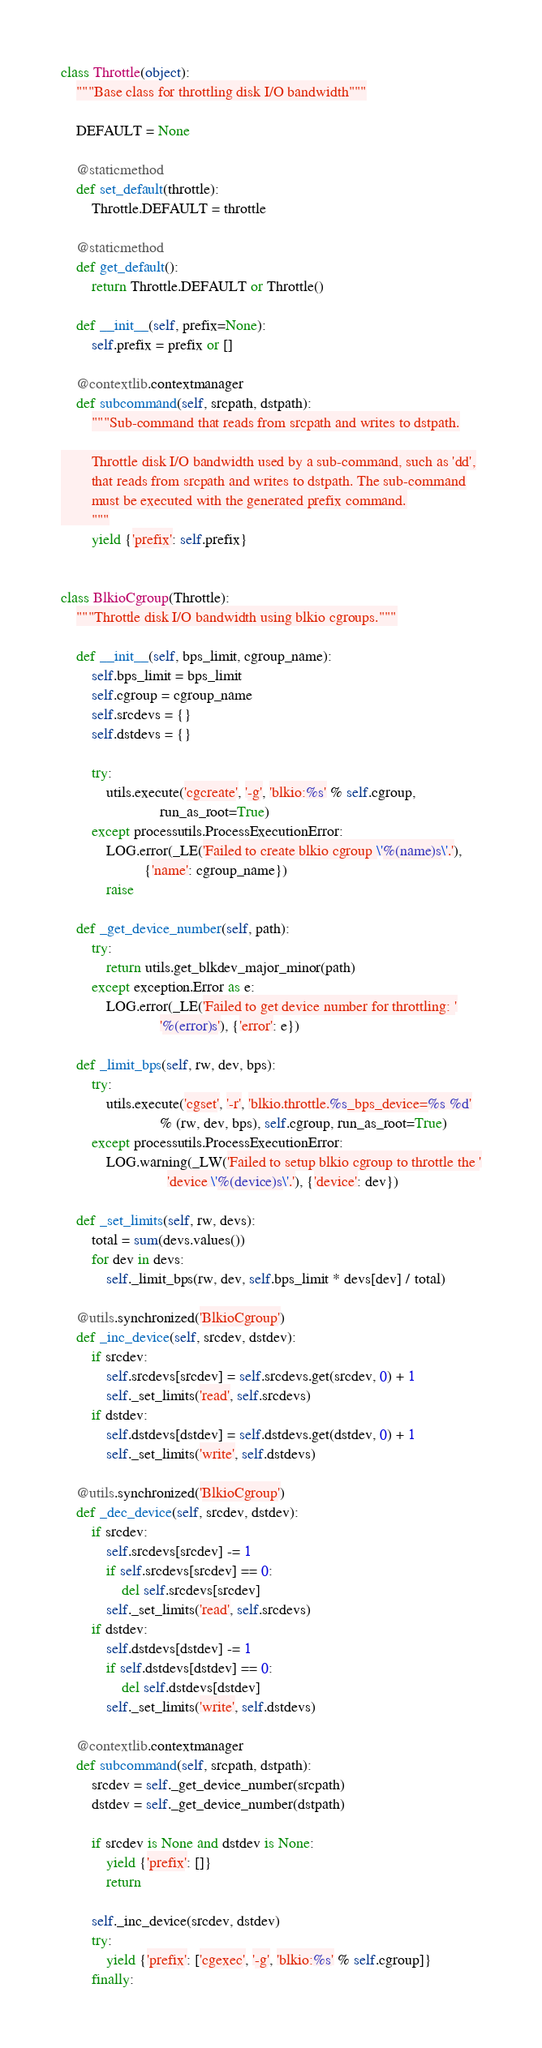<code> <loc_0><loc_0><loc_500><loc_500><_Python_>
class Throttle(object):
    """Base class for throttling disk I/O bandwidth"""

    DEFAULT = None

    @staticmethod
    def set_default(throttle):
        Throttle.DEFAULT = throttle

    @staticmethod
    def get_default():
        return Throttle.DEFAULT or Throttle()

    def __init__(self, prefix=None):
        self.prefix = prefix or []

    @contextlib.contextmanager
    def subcommand(self, srcpath, dstpath):
        """Sub-command that reads from srcpath and writes to dstpath.

        Throttle disk I/O bandwidth used by a sub-command, such as 'dd',
        that reads from srcpath and writes to dstpath. The sub-command
        must be executed with the generated prefix command.
        """
        yield {'prefix': self.prefix}


class BlkioCgroup(Throttle):
    """Throttle disk I/O bandwidth using blkio cgroups."""

    def __init__(self, bps_limit, cgroup_name):
        self.bps_limit = bps_limit
        self.cgroup = cgroup_name
        self.srcdevs = {}
        self.dstdevs = {}

        try:
            utils.execute('cgcreate', '-g', 'blkio:%s' % self.cgroup,
                          run_as_root=True)
        except processutils.ProcessExecutionError:
            LOG.error(_LE('Failed to create blkio cgroup \'%(name)s\'.'),
                      {'name': cgroup_name})
            raise

    def _get_device_number(self, path):
        try:
            return utils.get_blkdev_major_minor(path)
        except exception.Error as e:
            LOG.error(_LE('Failed to get device number for throttling: '
                          '%(error)s'), {'error': e})

    def _limit_bps(self, rw, dev, bps):
        try:
            utils.execute('cgset', '-r', 'blkio.throttle.%s_bps_device=%s %d'
                          % (rw, dev, bps), self.cgroup, run_as_root=True)
        except processutils.ProcessExecutionError:
            LOG.warning(_LW('Failed to setup blkio cgroup to throttle the '
                            'device \'%(device)s\'.'), {'device': dev})

    def _set_limits(self, rw, devs):
        total = sum(devs.values())
        for dev in devs:
            self._limit_bps(rw, dev, self.bps_limit * devs[dev] / total)

    @utils.synchronized('BlkioCgroup')
    def _inc_device(self, srcdev, dstdev):
        if srcdev:
            self.srcdevs[srcdev] = self.srcdevs.get(srcdev, 0) + 1
            self._set_limits('read', self.srcdevs)
        if dstdev:
            self.dstdevs[dstdev] = self.dstdevs.get(dstdev, 0) + 1
            self._set_limits('write', self.dstdevs)

    @utils.synchronized('BlkioCgroup')
    def _dec_device(self, srcdev, dstdev):
        if srcdev:
            self.srcdevs[srcdev] -= 1
            if self.srcdevs[srcdev] == 0:
                del self.srcdevs[srcdev]
            self._set_limits('read', self.srcdevs)
        if dstdev:
            self.dstdevs[dstdev] -= 1
            if self.dstdevs[dstdev] == 0:
                del self.dstdevs[dstdev]
            self._set_limits('write', self.dstdevs)

    @contextlib.contextmanager
    def subcommand(self, srcpath, dstpath):
        srcdev = self._get_device_number(srcpath)
        dstdev = self._get_device_number(dstpath)

        if srcdev is None and dstdev is None:
            yield {'prefix': []}
            return

        self._inc_device(srcdev, dstdev)
        try:
            yield {'prefix': ['cgexec', '-g', 'blkio:%s' % self.cgroup]}
        finally:</code> 